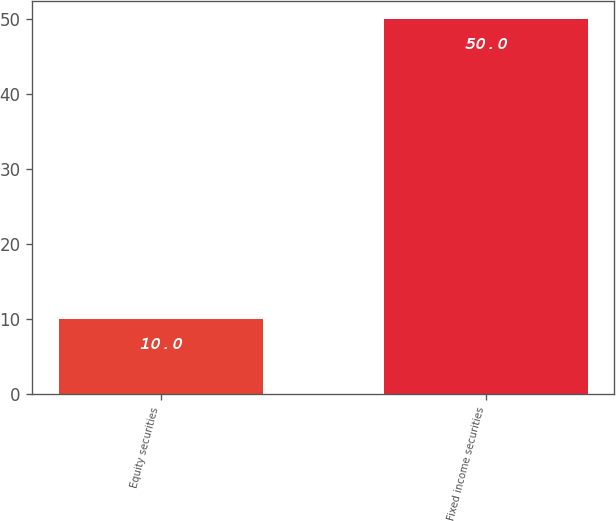Convert chart. <chart><loc_0><loc_0><loc_500><loc_500><bar_chart><fcel>Equity securities<fcel>Fixed income securities<nl><fcel>10<fcel>50<nl></chart> 